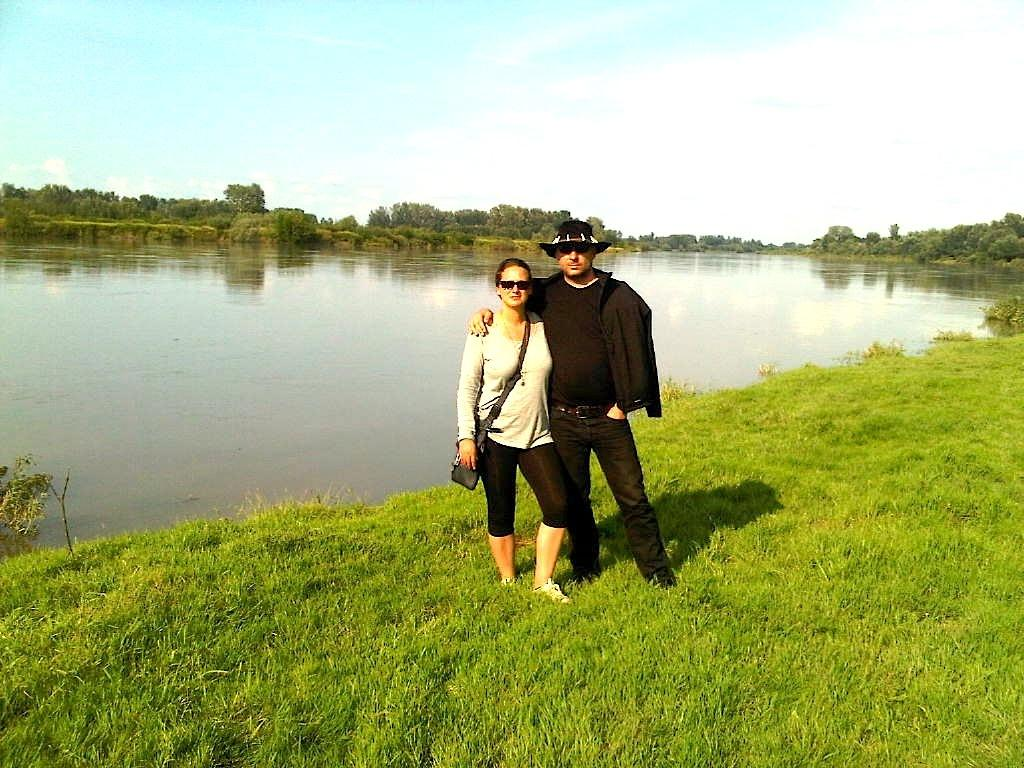How many people are in the image? There are two people in the image, a man and a woman. What are the positions of the man and woman in the image? Both the man and woman are standing in the image. What type of natural environment is visible in the image? There is grass, water, and trees visible in the image. What can be seen in the background of the image? The sky is visible in the background of the image. What type of laborer can be seen working on the letter in the image? There is no laborer or letter present in the image. What fact can be confirmed about the man and woman in the image? The fact that both the man and woman are standing can be confirmed from the image. 